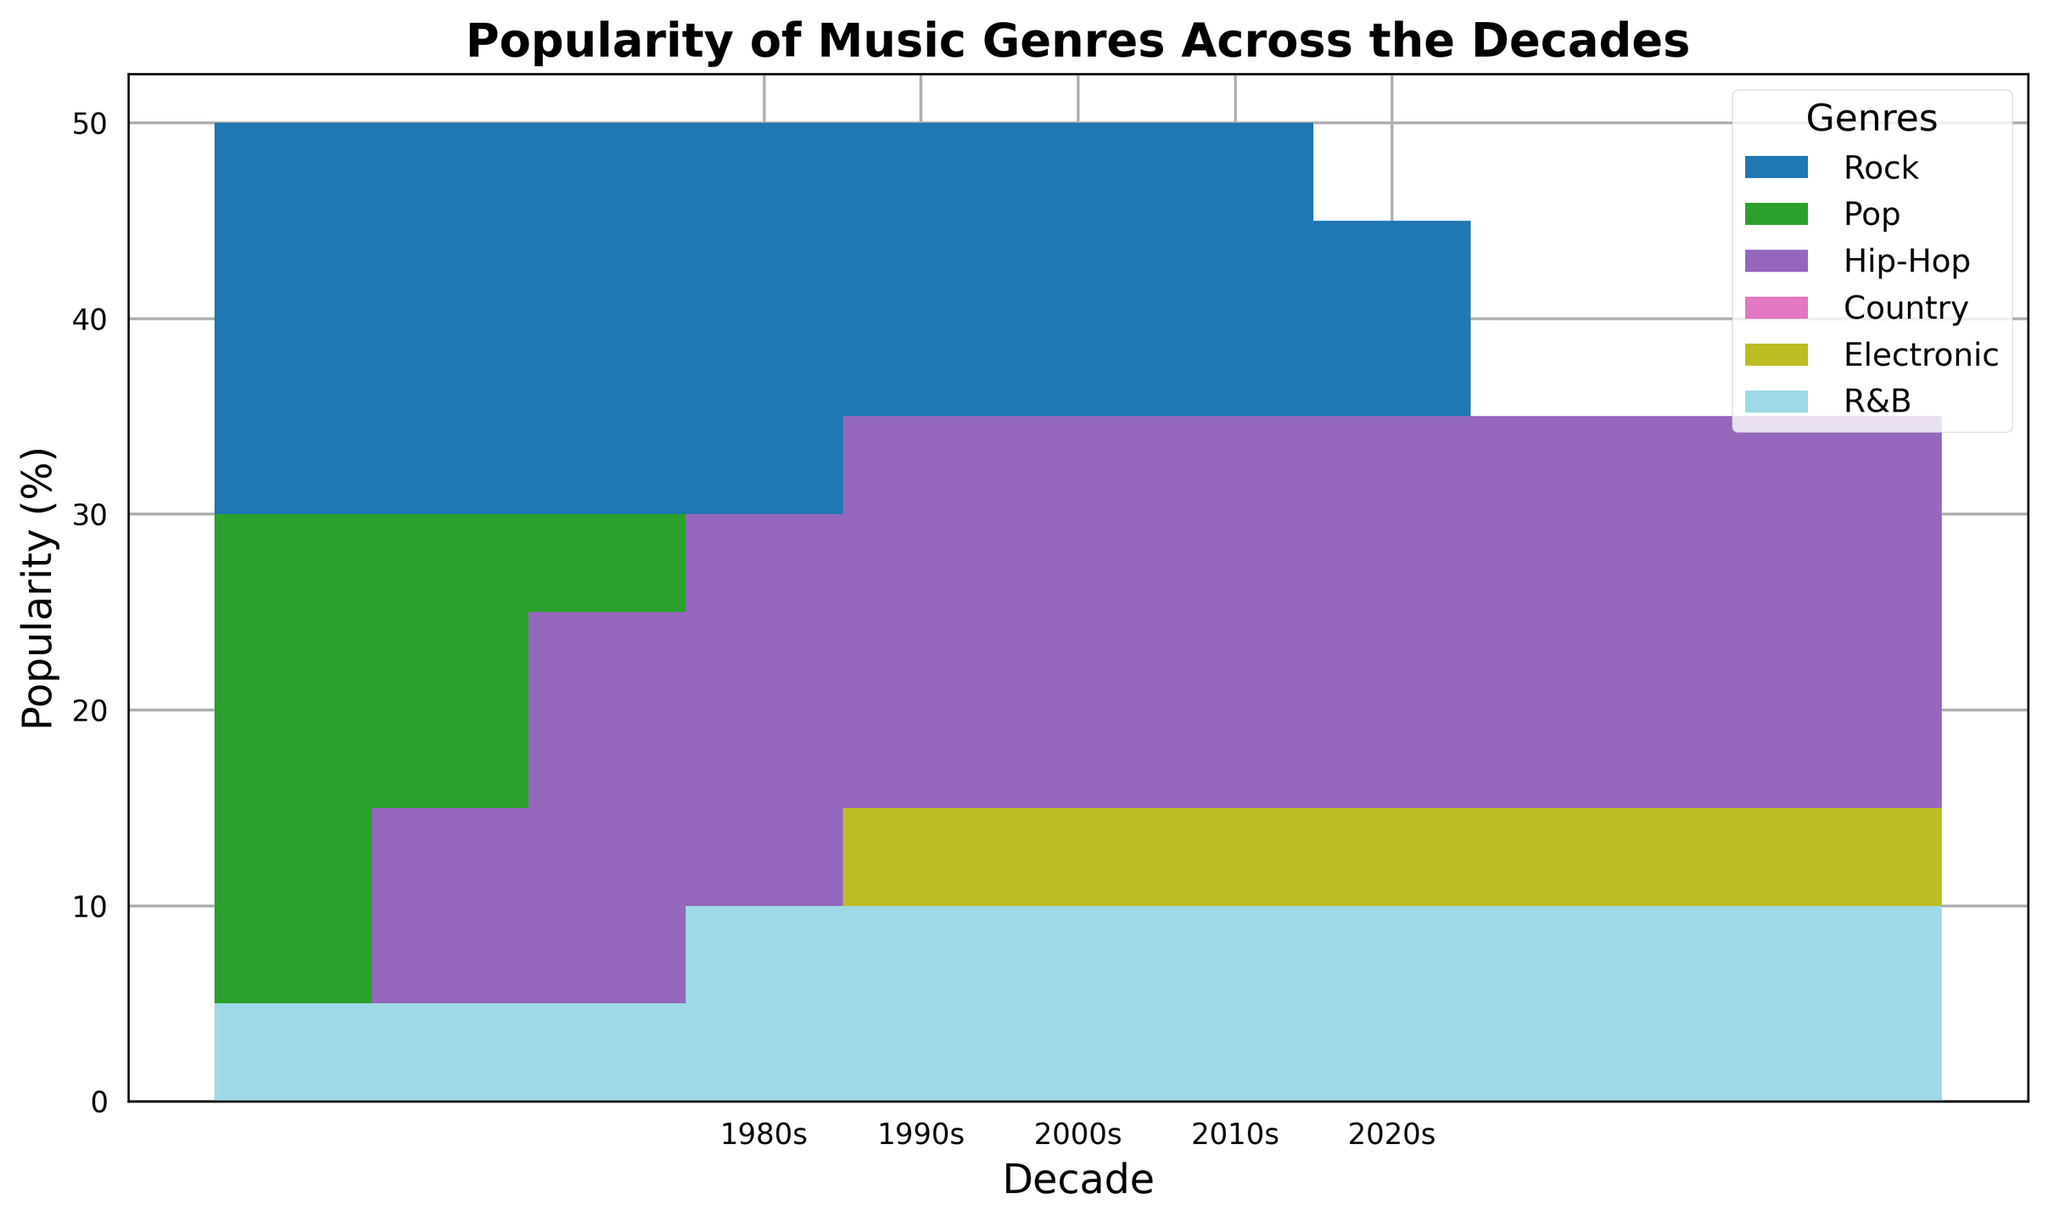Which genre saw the biggest increase in popularity from the 1980s to the 2020s? To identify the genre with the biggest increase, calculate the difference in popularity percentage for each genre between the 2020s and 1980s. Hip-Hop increased from 5% to 35%, a 30% increase.
Answer: Hip-Hop Which genres have consistently maintained the same popularity percentage over the decades? Check the values for each genre across all decades. Country maintained a constant 5% across all decades.
Answer: Country What’s the total popularity percentage of Rock and Hip-Hop combined in the 2010s? Add the popularity percentages of Rock (25%) and Hip-Hop (30%) for the 2010s. The total is 25% + 30% = 55%.
Answer: 55% Is there any decade where Pop and R&B combined are more popular than Rock? Compare the combined values of Pop and R&B with the value of Rock for each decade. Only in the 2020s, Pop and R&B combined (15% + 10% = 25%) are equal to Rock (20%).
Answer: No In which decade did Electronic music see its first notable increase in popularity? Examine the popularity of Electronic music across the decades. It increased from 5% in the 1990s to 10% in the 2010s.
Answer: 2010s Which genre had the sharpest decline in popularity from the 1980s to the 2020s? Calculate the difference in percentages for each genre between the 1980s and 2020s. Rock decreased from 50% to 20%, a 30% decline.
Answer: Rock In which decade did Hip-Hop surpass Rock in popularity? Compare the popularity percentages of Hip-Hop and Rock, decade by decade. Hip-Hop surpassed Rock in the 2010s (30% vs. 25%).
Answer: 2010s What's the average popularity of Pop across all decades? Add the popularity percentages of Pop for all decades and divide by the number of decades. (30 + 25 + 25 + 20 + 15) / 5 = 23%.
Answer: 23% What’s the difference in popularity between Rock and Electronic in the 2000s? Subtract the popularity of Electronic (5%) from Rock (35%) in the 2000s. The difference is 35% - 5% = 30%.
Answer: 30% Which genre in the 1990s had a similar popularity percentage to Pop in the 2020s? Identify the percentage of Pop in the 2020s (15%) and find a similar value in the 1990s. Pop in the 1990s is 25%, which is the closest.
Answer: None 